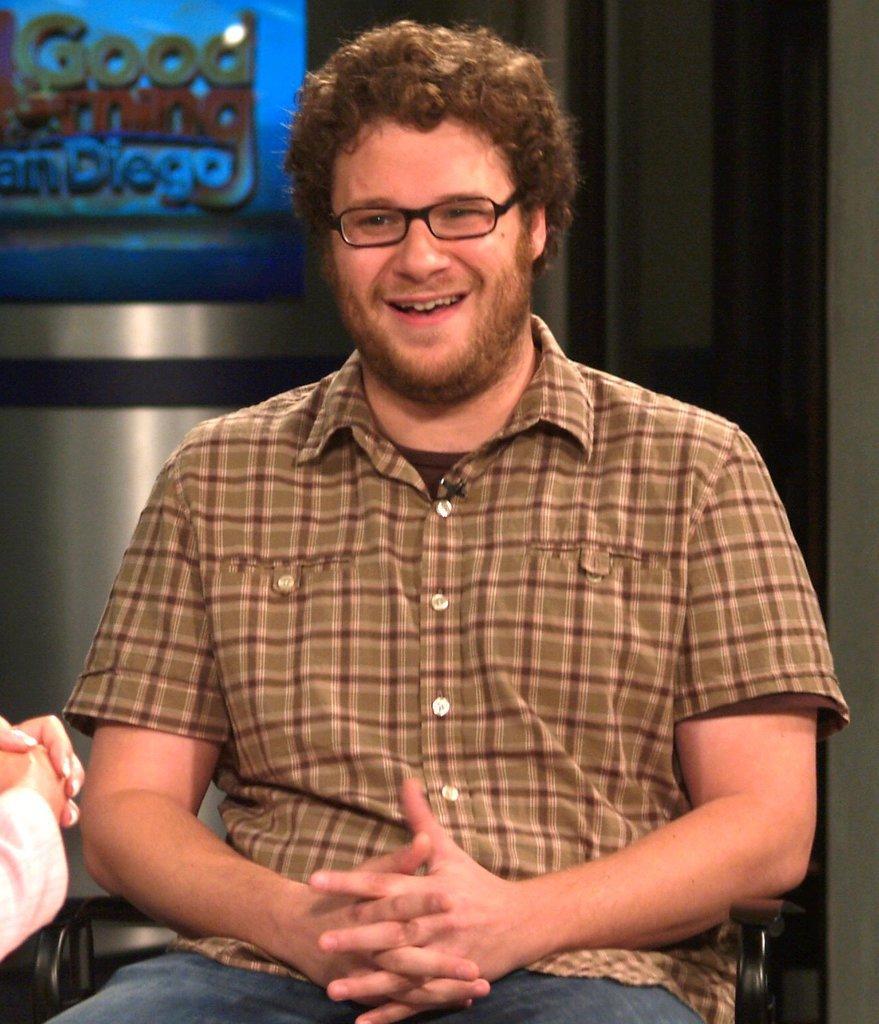In one or two sentences, can you explain what this image depicts? In the center of the image there is a person sitting on the chair. In the background we can see screen and wall. 